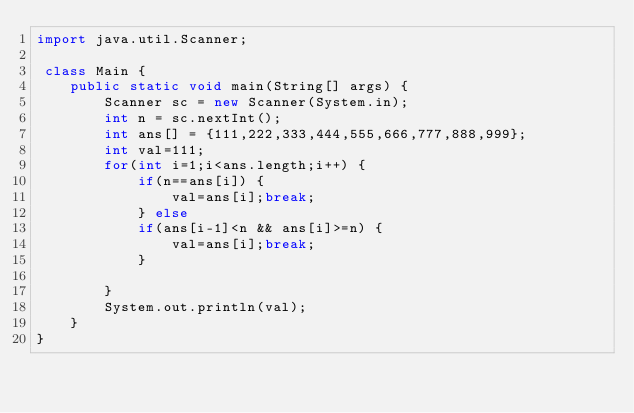<code> <loc_0><loc_0><loc_500><loc_500><_Java_>import java.util.Scanner;

 class Main {
	public static void main(String[] args) {
		Scanner sc = new Scanner(System.in);
		int n = sc.nextInt();
		int ans[] = {111,222,333,444,555,666,777,888,999};
		int val=111;
		for(int i=1;i<ans.length;i++) {
			if(n==ans[i]) {
				val=ans[i];break;
			} else
			if(ans[i-1]<n && ans[i]>=n) {
				val=ans[i];break;
			}
				
		}
		System.out.println(val);
	}
}
</code> 